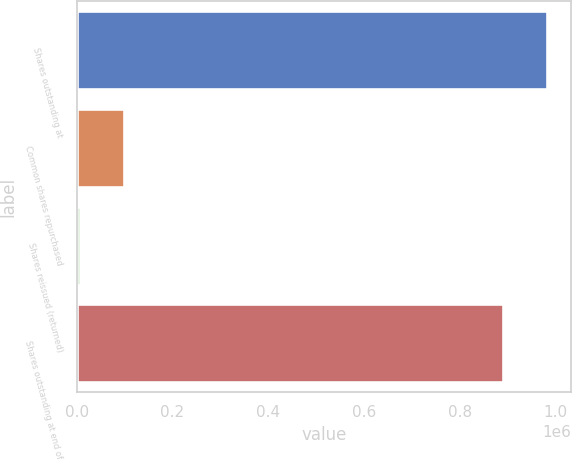Convert chart. <chart><loc_0><loc_0><loc_500><loc_500><bar_chart><fcel>Shares outstanding at<fcel>Common shares repurchased<fcel>Shares reissued (returned)<fcel>Shares outstanding at end of<nl><fcel>982646<fcel>98475.5<fcel>6554<fcel>890724<nl></chart> 